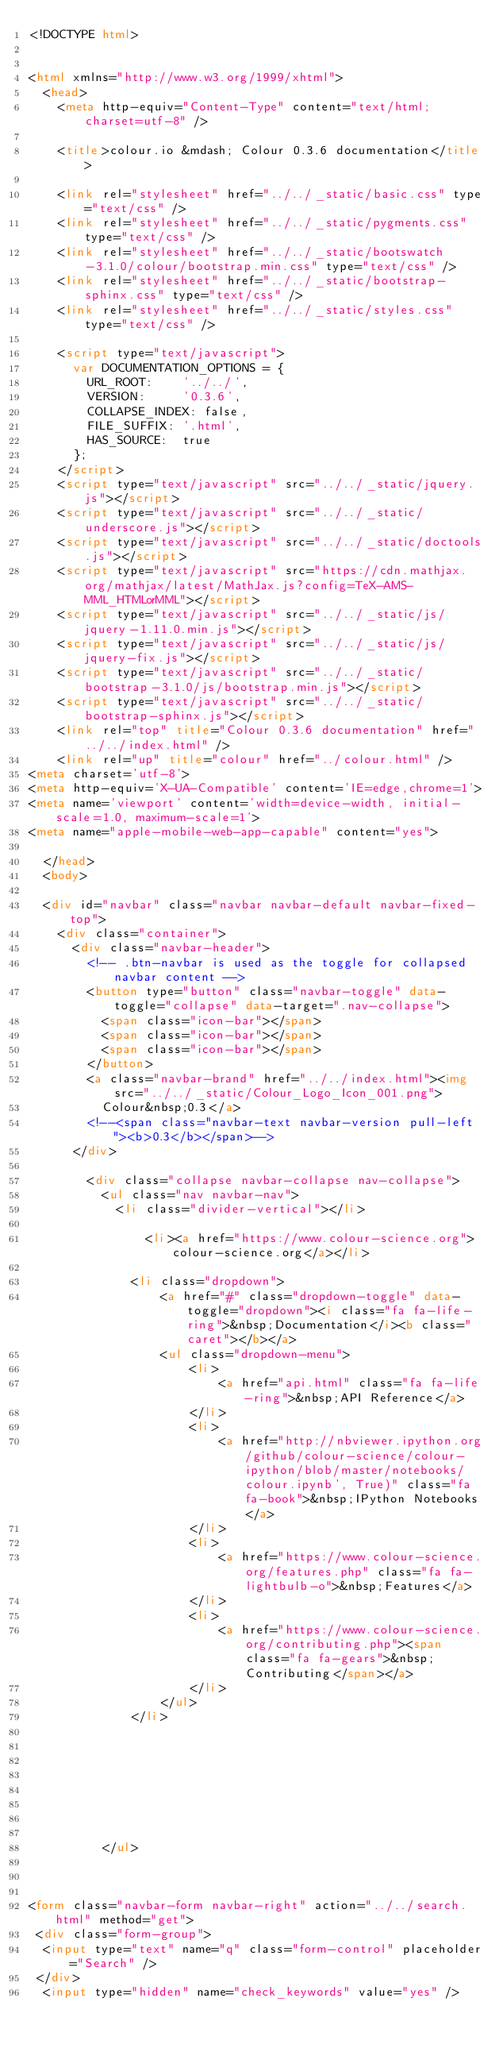<code> <loc_0><loc_0><loc_500><loc_500><_HTML_><!DOCTYPE html>


<html xmlns="http://www.w3.org/1999/xhtml">
  <head>
    <meta http-equiv="Content-Type" content="text/html; charset=utf-8" />
    
    <title>colour.io &mdash; Colour 0.3.6 documentation</title>
    
    <link rel="stylesheet" href="../../_static/basic.css" type="text/css" />
    <link rel="stylesheet" href="../../_static/pygments.css" type="text/css" />
    <link rel="stylesheet" href="../../_static/bootswatch-3.1.0/colour/bootstrap.min.css" type="text/css" />
    <link rel="stylesheet" href="../../_static/bootstrap-sphinx.css" type="text/css" />
    <link rel="stylesheet" href="../../_static/styles.css" type="text/css" />
    
    <script type="text/javascript">
      var DOCUMENTATION_OPTIONS = {
        URL_ROOT:    '../../',
        VERSION:     '0.3.6',
        COLLAPSE_INDEX: false,
        FILE_SUFFIX: '.html',
        HAS_SOURCE:  true
      };
    </script>
    <script type="text/javascript" src="../../_static/jquery.js"></script>
    <script type="text/javascript" src="../../_static/underscore.js"></script>
    <script type="text/javascript" src="../../_static/doctools.js"></script>
    <script type="text/javascript" src="https://cdn.mathjax.org/mathjax/latest/MathJax.js?config=TeX-AMS-MML_HTMLorMML"></script>
    <script type="text/javascript" src="../../_static/js/jquery-1.11.0.min.js"></script>
    <script type="text/javascript" src="../../_static/js/jquery-fix.js"></script>
    <script type="text/javascript" src="../../_static/bootstrap-3.1.0/js/bootstrap.min.js"></script>
    <script type="text/javascript" src="../../_static/bootstrap-sphinx.js"></script>
    <link rel="top" title="Colour 0.3.6 documentation" href="../../index.html" />
    <link rel="up" title="colour" href="../colour.html" />
<meta charset='utf-8'>
<meta http-equiv='X-UA-Compatible' content='IE=edge,chrome=1'>
<meta name='viewport' content='width=device-width, initial-scale=1.0, maximum-scale=1'>
<meta name="apple-mobile-web-app-capable" content="yes">

  </head>
  <body>

  <div id="navbar" class="navbar navbar-default navbar-fixed-top">
    <div class="container">
      <div class="navbar-header">
        <!-- .btn-navbar is used as the toggle for collapsed navbar content -->
        <button type="button" class="navbar-toggle" data-toggle="collapse" data-target=".nav-collapse">
          <span class="icon-bar"></span>
          <span class="icon-bar"></span>
          <span class="icon-bar"></span>
        </button>
        <a class="navbar-brand" href="../../index.html"><img src="../../_static/Colour_Logo_Icon_001.png">
          Colour&nbsp;0.3</a>
        <!--<span class="navbar-text navbar-version pull-left"><b>0.3</b></span>-->
      </div>

        <div class="collapse navbar-collapse nav-collapse">
          <ul class="nav navbar-nav">
            <li class="divider-vertical"></li>
            
                <li><a href="https://www.colour-science.org">colour-science.org</a></li>
            
              <li class="dropdown">
                  <a href="#" class="dropdown-toggle" data-toggle="dropdown"><i class="fa fa-life-ring">&nbsp;Documentation</i><b class="caret"></b></a>
                  <ul class="dropdown-menu">
                      <li>
                          <a href="api.html" class="fa fa-life-ring">&nbsp;API Reference</a>
                      </li>
                      <li>
                          <a href="http://nbviewer.ipython.org/github/colour-science/colour-ipython/blob/master/notebooks/colour.ipynb', True)" class="fa fa-book">&nbsp;IPython Notebooks</a>
                      </li>
                      <li>
                          <a href="https://www.colour-science.org/features.php" class="fa fa-lightbulb-o">&nbsp;Features</a>
                      </li>
                      <li>
                          <a href="https://www.colour-science.org/contributing.php"><span class="fa fa-gears">&nbsp;Contributing</span></a>
                      </li>
                  </ul>
              </li>
            
              
                
              
            
            
            
            
          </ul>

          
            
<form class="navbar-form navbar-right" action="../../search.html" method="get">
 <div class="form-group">
  <input type="text" name="q" class="form-control" placeholder="Search" />
 </div>
  <input type="hidden" name="check_keywords" value="yes" /></code> 